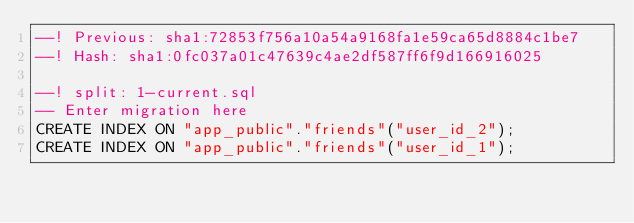<code> <loc_0><loc_0><loc_500><loc_500><_SQL_>--! Previous: sha1:72853f756a10a54a9168fa1e59ca65d8884c1be7
--! Hash: sha1:0fc037a01c47639c4ae2df587ff6f9d166916025

--! split: 1-current.sql
-- Enter migration here
CREATE INDEX ON "app_public"."friends"("user_id_2");
CREATE INDEX ON "app_public"."friends"("user_id_1");
</code> 